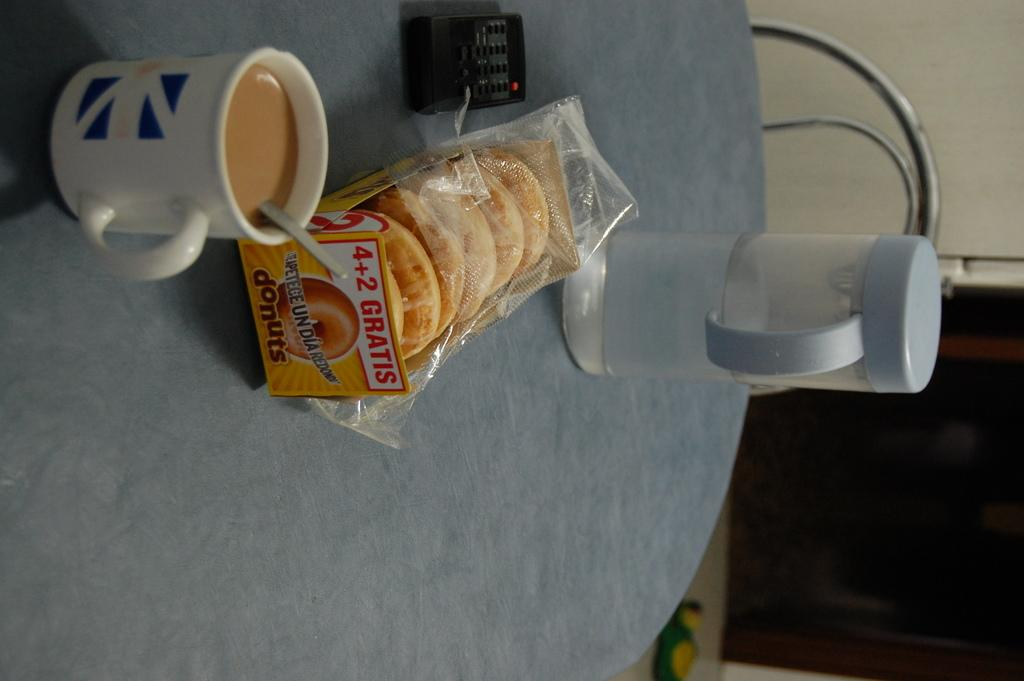<image>
Relay a brief, clear account of the picture shown. A cup of coffee sits on a table next to a pack of donuts advertising 4+2 GRATIS. 